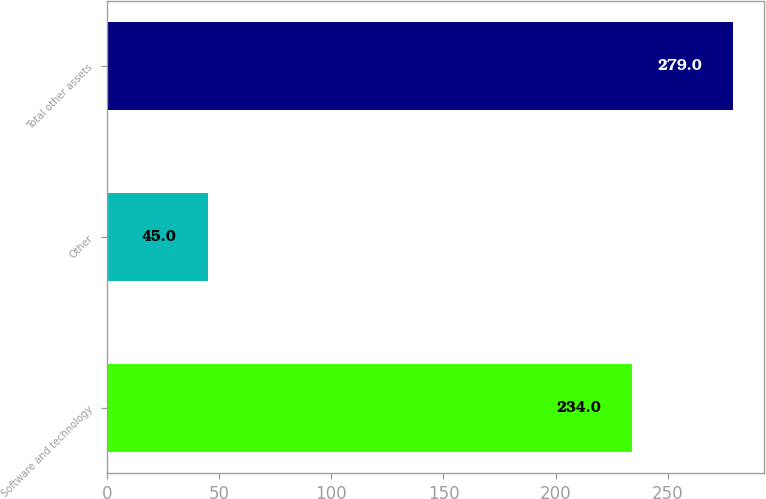<chart> <loc_0><loc_0><loc_500><loc_500><bar_chart><fcel>Software and technology<fcel>Other<fcel>Total other assets<nl><fcel>234<fcel>45<fcel>279<nl></chart> 